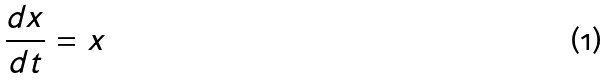<formula> <loc_0><loc_0><loc_500><loc_500>\frac { d x } { d t } = x</formula> 